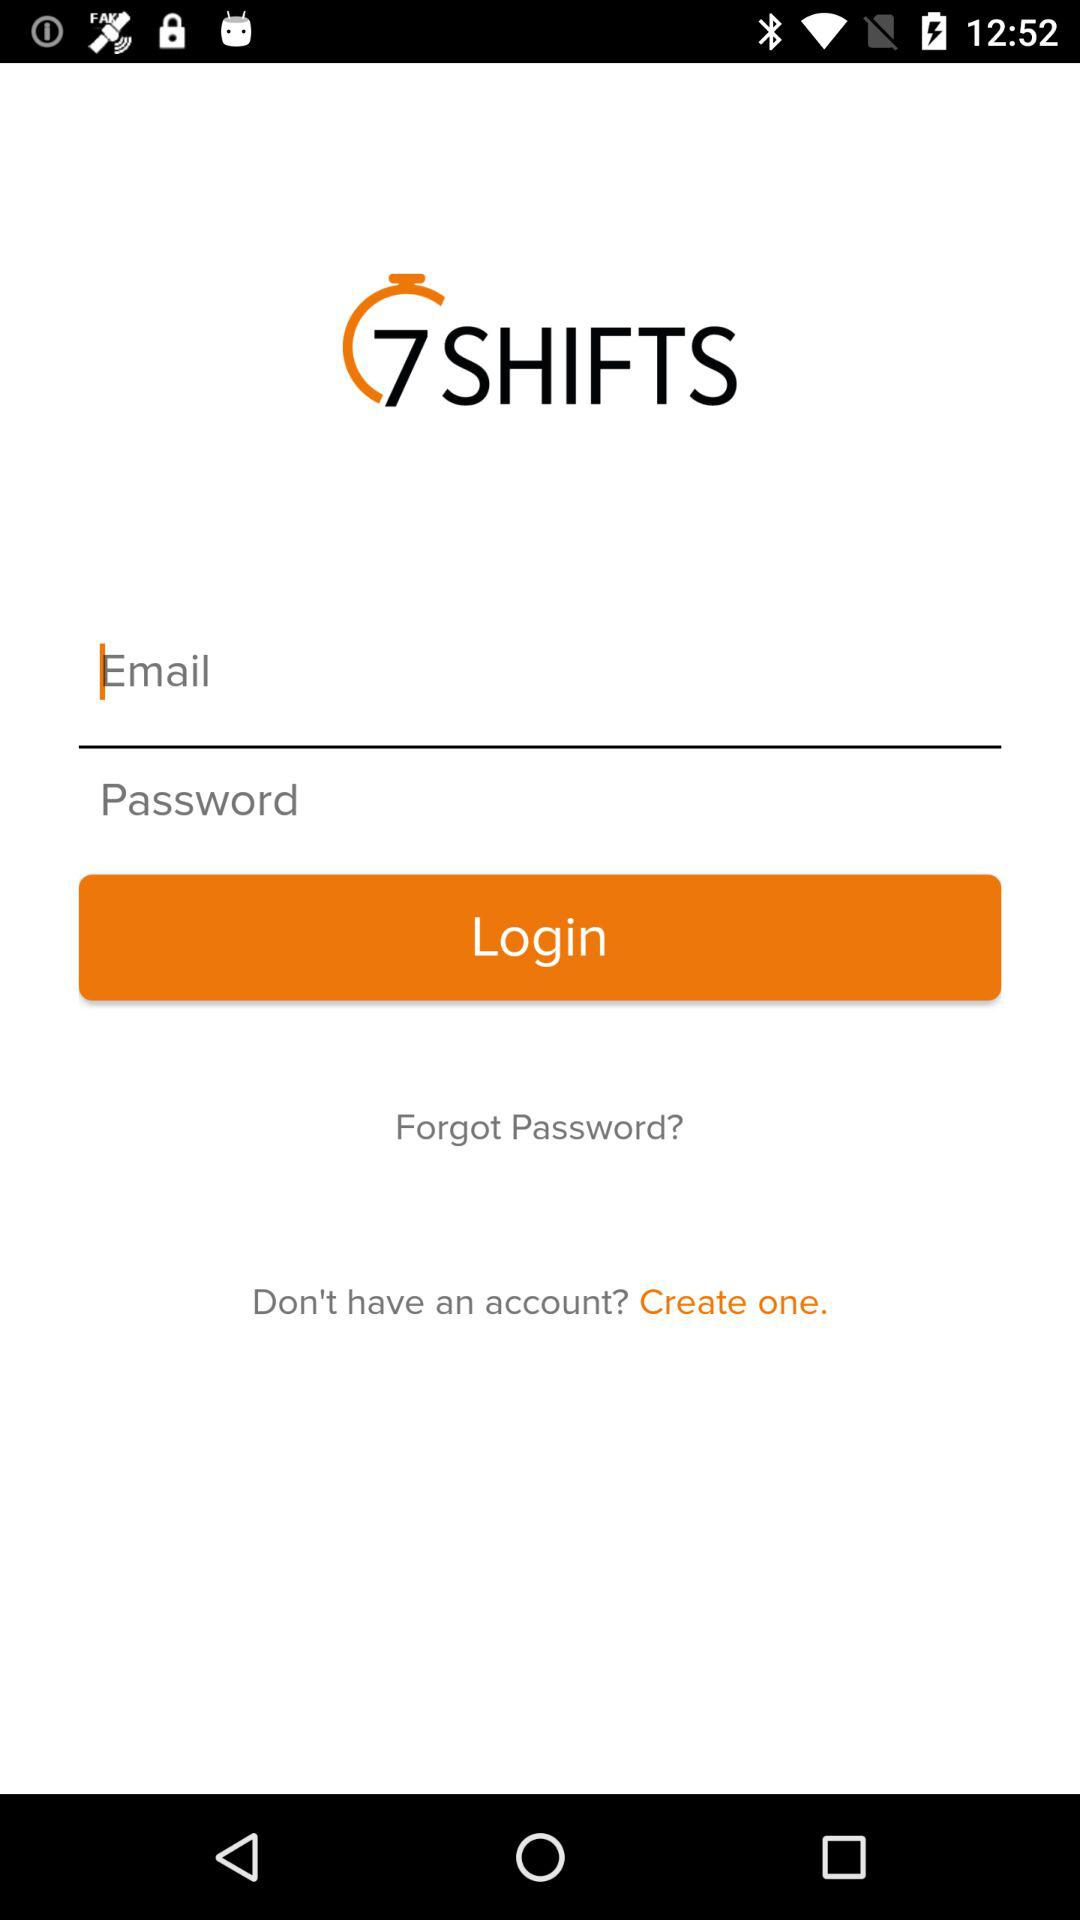What is the name of the application? The name of the application is "7 SHIFTS". 